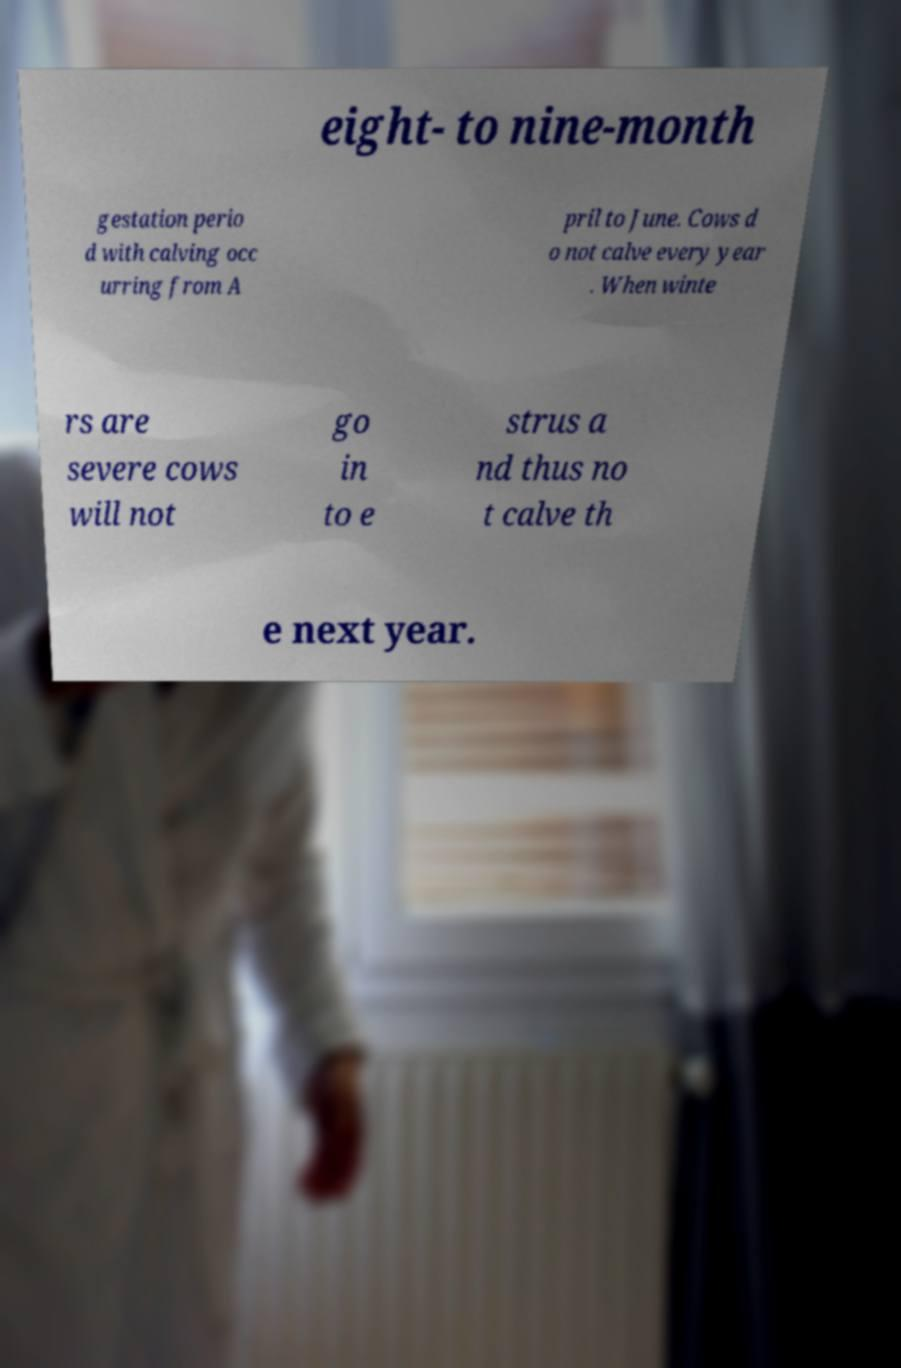Could you extract and type out the text from this image? eight- to nine-month gestation perio d with calving occ urring from A pril to June. Cows d o not calve every year . When winte rs are severe cows will not go in to e strus a nd thus no t calve th e next year. 